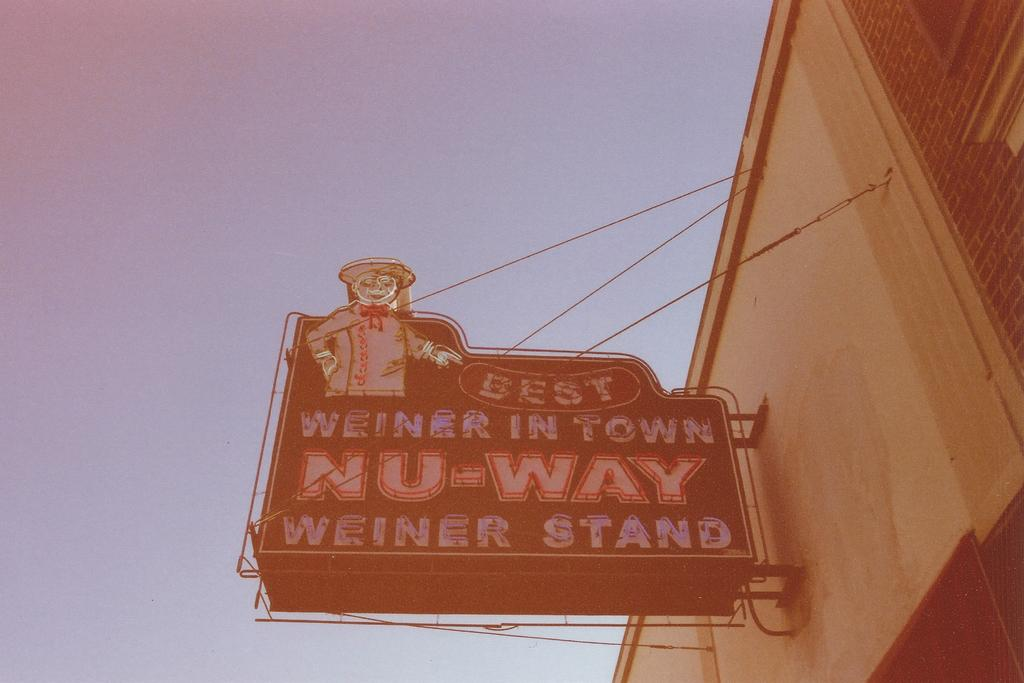What structure is located on the right side of the image? There is a building on the right side of the image. What is attached to the wall of the building? A board is attached to the wall of the building. What can be found on the board? There is text on the board. What is visible in the background of the image? The sky is visible in the background of the image. What type of lumber is the mother using to clear her throat in the image? There is no mother or lumber present in the image. 